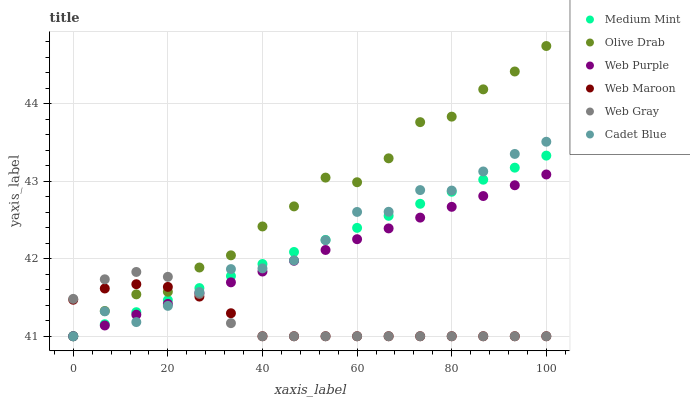Does Web Maroon have the minimum area under the curve?
Answer yes or no. Yes. Does Olive Drab have the maximum area under the curve?
Answer yes or no. Yes. Does Cadet Blue have the minimum area under the curve?
Answer yes or no. No. Does Cadet Blue have the maximum area under the curve?
Answer yes or no. No. Is Web Purple the smoothest?
Answer yes or no. Yes. Is Olive Drab the roughest?
Answer yes or no. Yes. Is Cadet Blue the smoothest?
Answer yes or no. No. Is Cadet Blue the roughest?
Answer yes or no. No. Does Medium Mint have the lowest value?
Answer yes or no. Yes. Does Olive Drab have the highest value?
Answer yes or no. Yes. Does Cadet Blue have the highest value?
Answer yes or no. No. Does Web Gray intersect Medium Mint?
Answer yes or no. Yes. Is Web Gray less than Medium Mint?
Answer yes or no. No. Is Web Gray greater than Medium Mint?
Answer yes or no. No. 